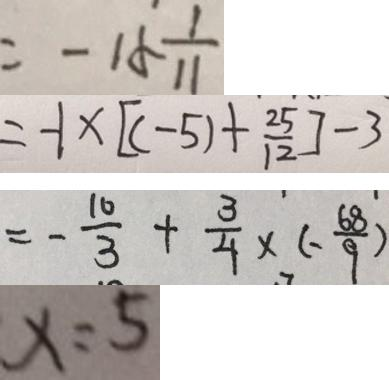Convert formula to latex. <formula><loc_0><loc_0><loc_500><loc_500>= - 1 5 \frac { 1 } { 1 1 } 
 = - 1 \times [ ( - 5 ) + \frac { 2 5 } { 1 2 } ] - 3 
 = - \frac { 1 0 } { 3 } + \frac { 3 } { 4 } \times ( - \frac { 6 8 } { 9 } ) 
 x = 5</formula> 